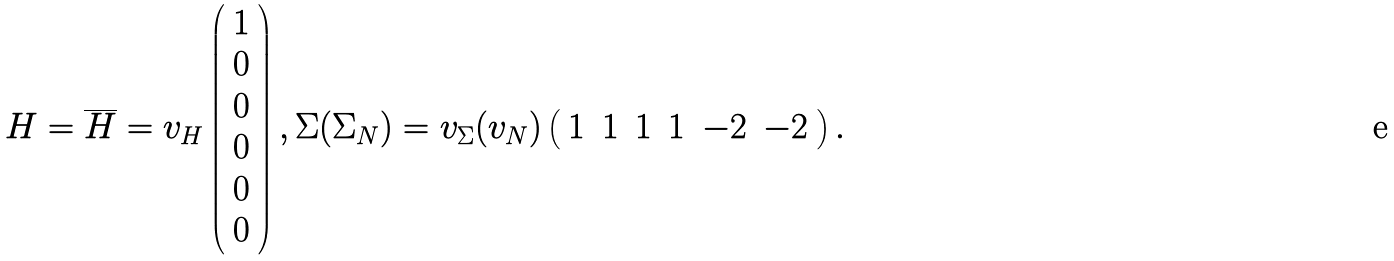<formula> <loc_0><loc_0><loc_500><loc_500>H = \overline { H } = v _ { H } \left ( \begin{array} { c } { 1 } \\ { 0 } \\ { 0 } \\ { 0 } \\ { 0 } \\ { 0 } \end{array} \right ) , \Sigma ( \Sigma _ { N } ) = v _ { \Sigma } ( v _ { N } ) \left ( \begin{array} { c c c c c c } { 1 } & { 1 } & { 1 } & { 1 } & { - 2 } & { - 2 } \end{array} \right ) .</formula> 